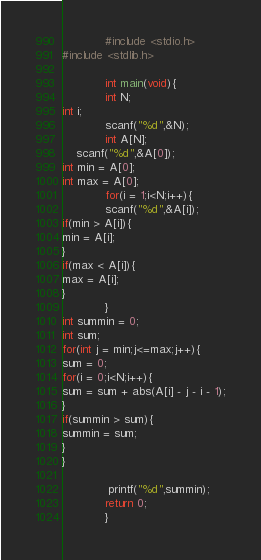Convert code to text. <code><loc_0><loc_0><loc_500><loc_500><_C++_>            #include <stdio.h>
#include <stdlib.h>
             
            int main(void){
            int N;
int i;
            scanf("%d",&N);
            int A[N];
    scanf("%d",&A[0]);
int min = A[0];
int max = A[0];
            for(i = 1;i<N;i++){
            scanf("%d",&A[i]);
if(min > A[i]){
min = A[i];
}
if(max < A[i]){
max = A[i];
}
            }
int summin = 0;
int sum;
for(int j = min;j<=max;j++){
sum = 0;
for(i = 0;i<N;i++){
sum = sum + abs(A[i] - j - i - 1);
}
if(summin > sum){
summin = sum;
}
}
        
             printf("%d",summin);
            return 0;
            }</code> 